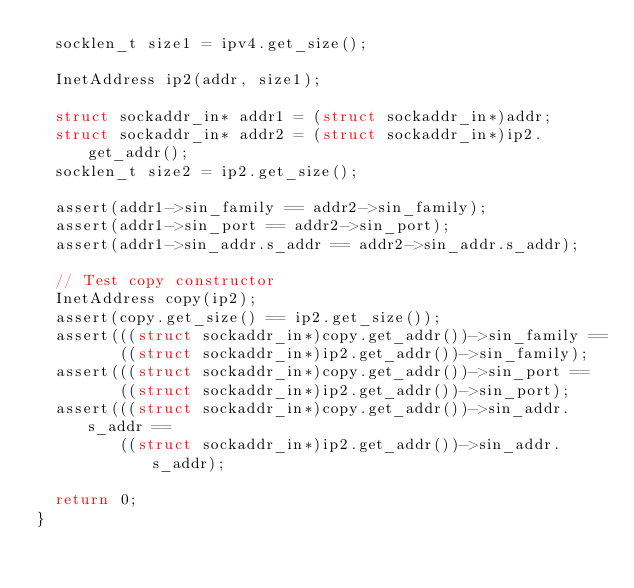<code> <loc_0><loc_0><loc_500><loc_500><_C++_>  socklen_t size1 = ipv4.get_size();

  InetAddress ip2(addr, size1);

  struct sockaddr_in* addr1 = (struct sockaddr_in*)addr;
  struct sockaddr_in* addr2 = (struct sockaddr_in*)ip2.get_addr();
  socklen_t size2 = ip2.get_size();

  assert(addr1->sin_family == addr2->sin_family);
  assert(addr1->sin_port == addr2->sin_port);
  assert(addr1->sin_addr.s_addr == addr2->sin_addr.s_addr);

  // Test copy constructor
  InetAddress copy(ip2);
  assert(copy.get_size() == ip2.get_size());
  assert(((struct sockaddr_in*)copy.get_addr())->sin_family ==
         ((struct sockaddr_in*)ip2.get_addr())->sin_family);
  assert(((struct sockaddr_in*)copy.get_addr())->sin_port ==
         ((struct sockaddr_in*)ip2.get_addr())->sin_port);
  assert(((struct sockaddr_in*)copy.get_addr())->sin_addr.s_addr ==
         ((struct sockaddr_in*)ip2.get_addr())->sin_addr.s_addr);

  return 0;
}</code> 